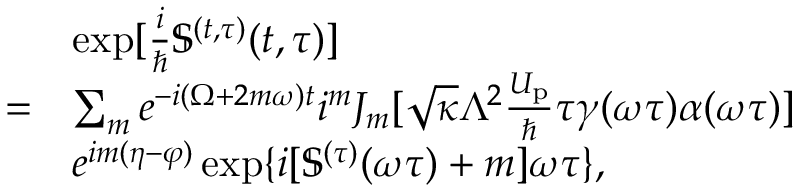<formula> <loc_0><loc_0><loc_500><loc_500>\begin{array} { r l } & { \exp [ { \frac { i } { } \mathbb { S } ^ { ( t , \tau ) } ( t , \tau ) } ] } \\ { = } & { \sum _ { m } e ^ { - i ( \Omega + 2 m \omega ) t } i ^ { m } J _ { m } [ \sqrt { \kappa } \Lambda ^ { 2 } \frac { U _ { p } } { } \tau \gamma ( \omega \tau ) \alpha ( \omega \tau ) ] } \\ & { e ^ { i m ( \eta - \varphi ) } \exp \{ i [ \mathbb { S } ^ { ( \tau ) } ( \omega \tau ) + m ] \omega \tau \} , } \end{array}</formula> 